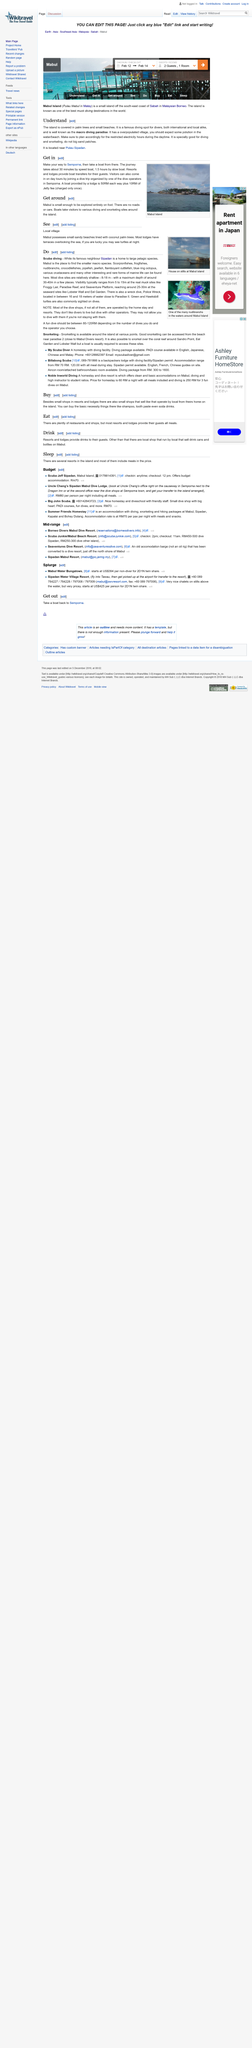Indicate a few pertinent items in this graphic. The photograph shows Mabul Island. Mabul Island is small enough to be explored entirely on foot. Boats provided by a lodge cost 50RM each way, plus a 10RM jetty fee that is only charged once. 